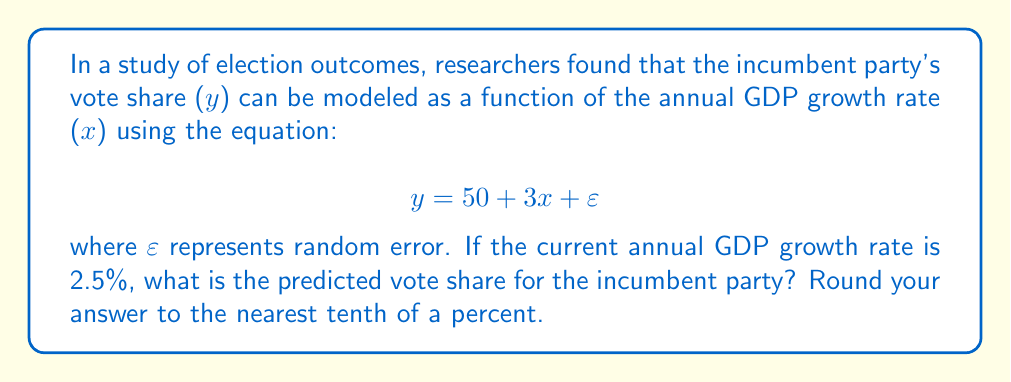Give your solution to this math problem. To solve this problem, we'll follow these steps:

1. Identify the given information:
   - The model equation: $y = 50 + 3x + \varepsilon$
   - $x$ represents the annual GDP growth rate
   - $y$ represents the incumbent party's vote share
   - Current GDP growth rate: 2.5%

2. Substitute the given GDP growth rate into the equation:
   $y = 50 + 3(2.5) + \varepsilon$

3. Simplify the equation:
   $y = 50 + 7.5 + \varepsilon$
   $y = 57.5 + \varepsilon$

4. Since $\varepsilon$ represents random error, we can ignore it for prediction purposes:
   $y \approx 57.5$

5. Round the result to the nearest tenth of a percent:
   $y \approx 57.5\%$

This prediction suggests that based on the current economic performance (GDP growth rate of 2.5%), the incumbent party is expected to receive approximately 57.5% of the vote share in the upcoming election.
Answer: 57.5% 